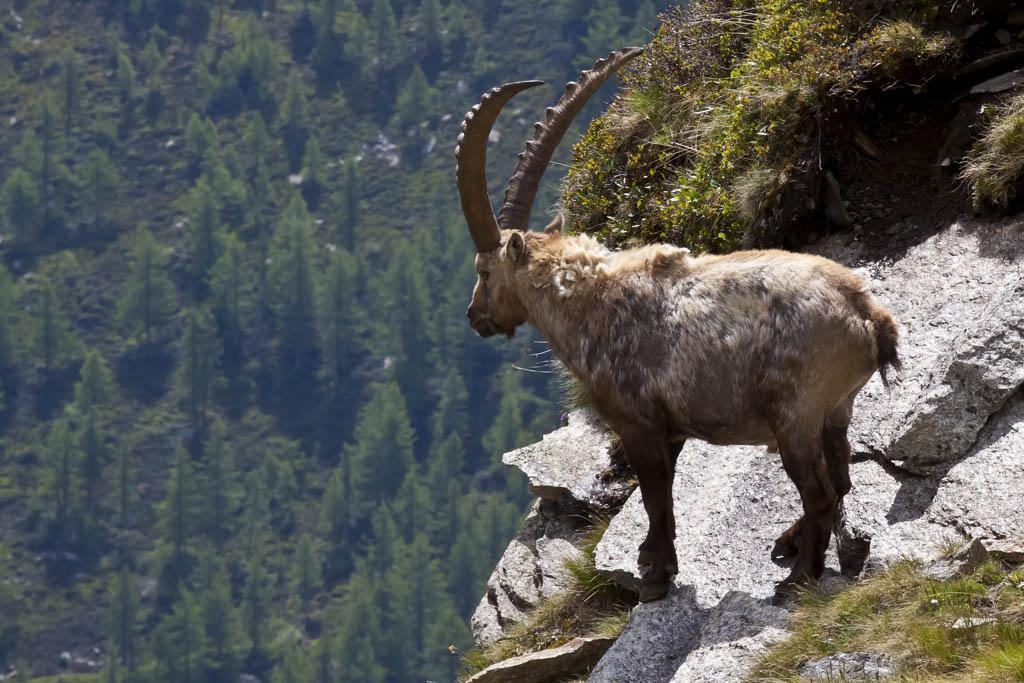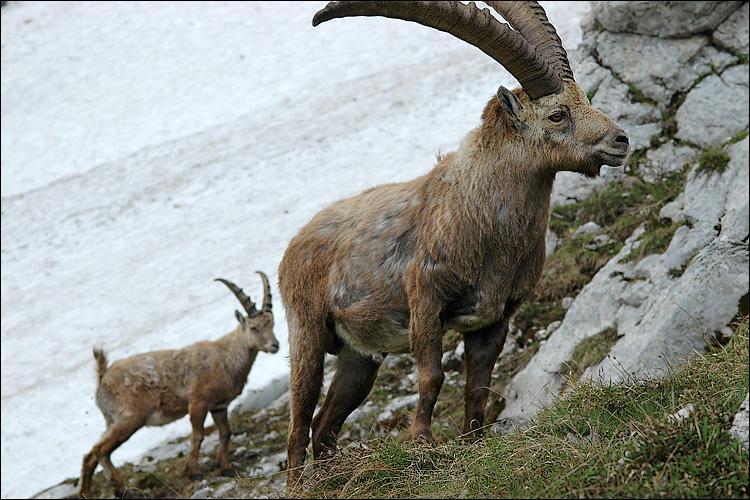The first image is the image on the left, the second image is the image on the right. Given the left and right images, does the statement "One image contains more than one animal." hold true? Answer yes or no. Yes. The first image is the image on the left, the second image is the image on the right. Considering the images on both sides, is "There is exactly one animal in the image on the right." valid? Answer yes or no. No. 